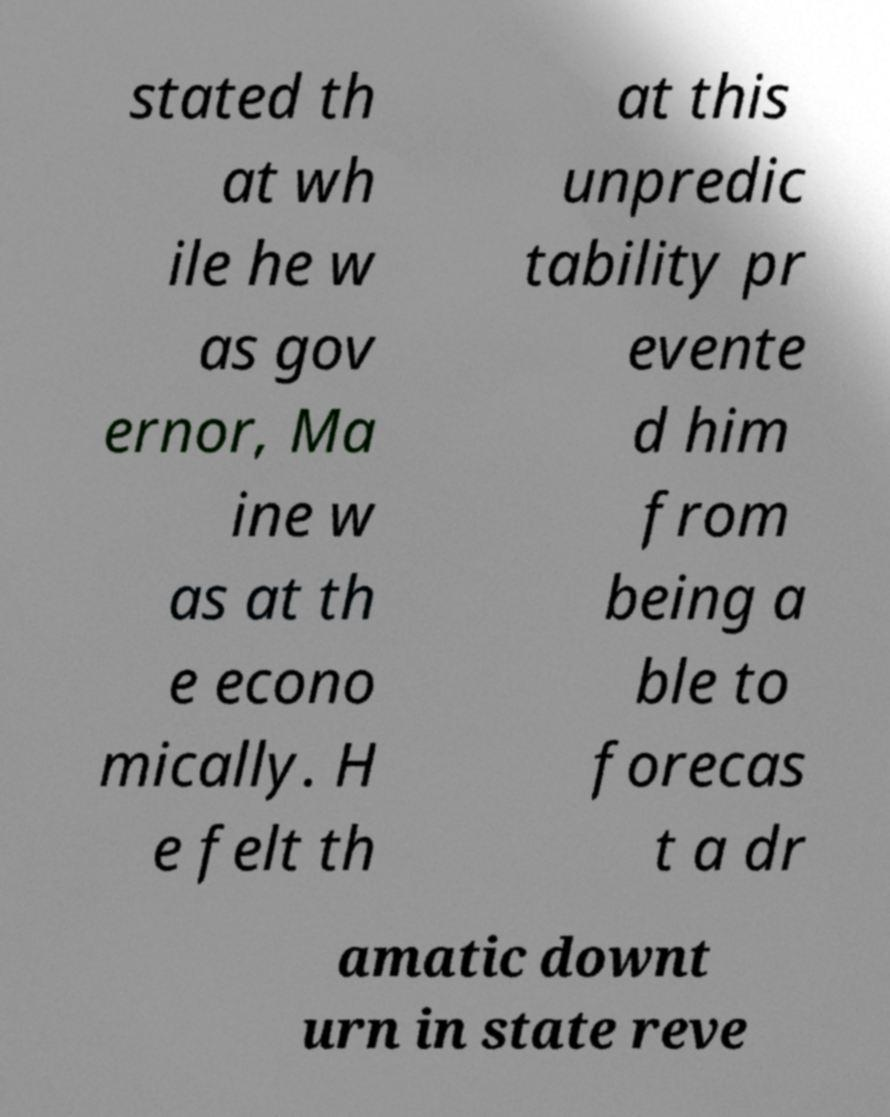Could you extract and type out the text from this image? stated th at wh ile he w as gov ernor, Ma ine w as at th e econo mically. H e felt th at this unpredic tability pr evente d him from being a ble to forecas t a dr amatic downt urn in state reve 